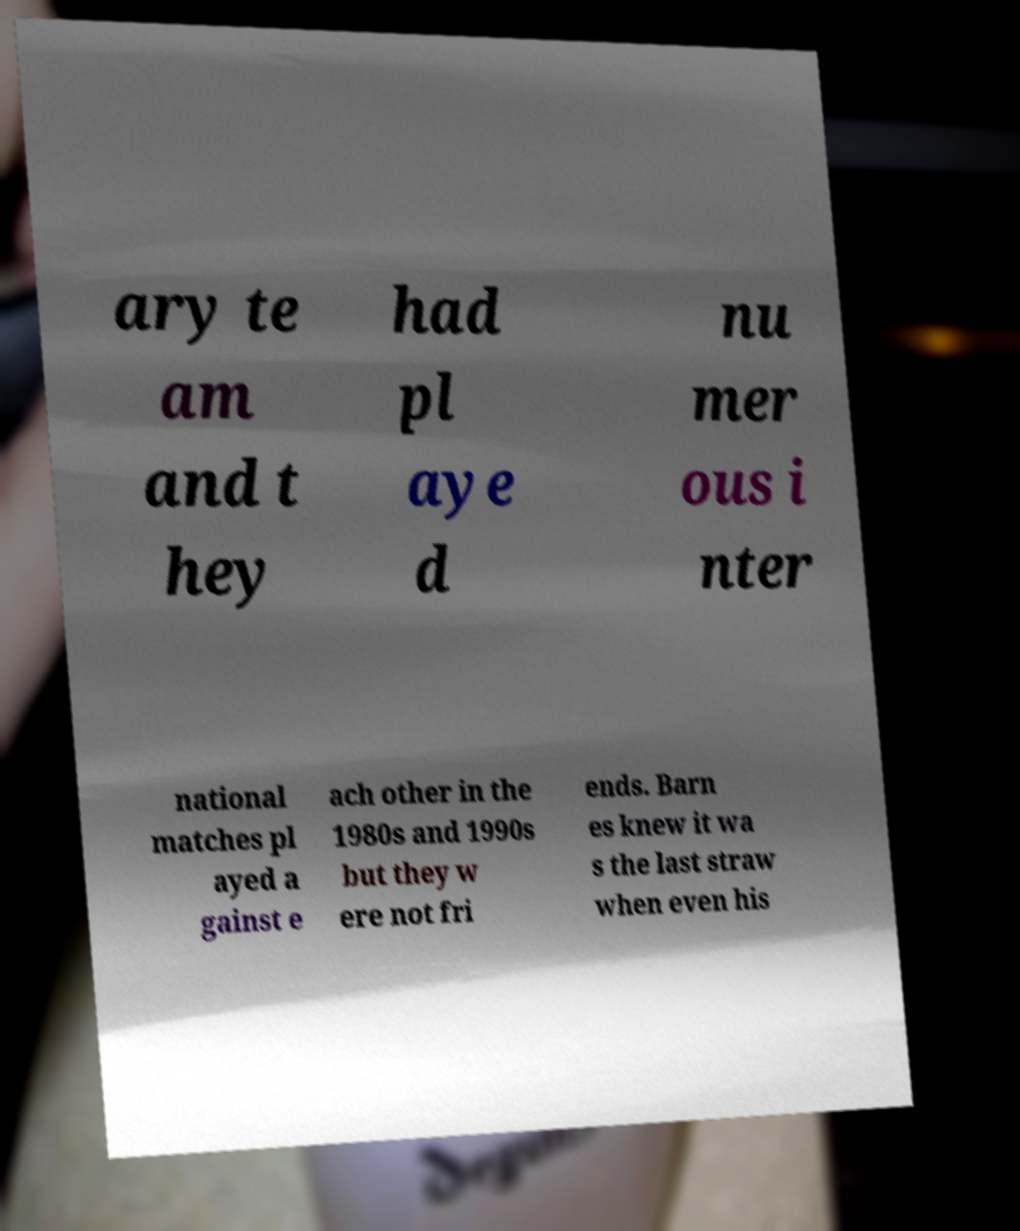I need the written content from this picture converted into text. Can you do that? ary te am and t hey had pl aye d nu mer ous i nter national matches pl ayed a gainst e ach other in the 1980s and 1990s but they w ere not fri ends. Barn es knew it wa s the last straw when even his 